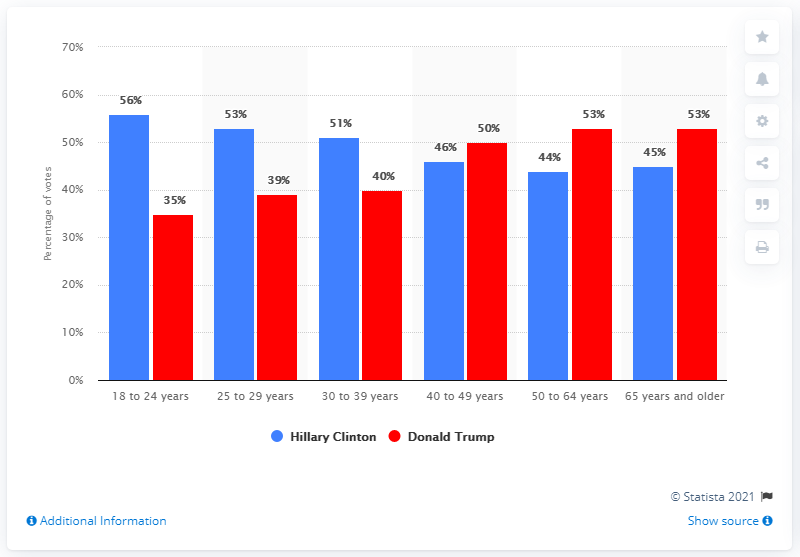Indicate a few pertinent items in this graphic. According to data, 56% of voters aged 18-24 voted for Hillary Clinton in the 2016 presidential election. In the age group of 18 to 24 years, the difference between the votes received by Hillary Clinton and Donald Trump was maximum. Donald Trump received 40-49 year olds' votes representing (percentage of total votes received) of the total votes cast in the election. 